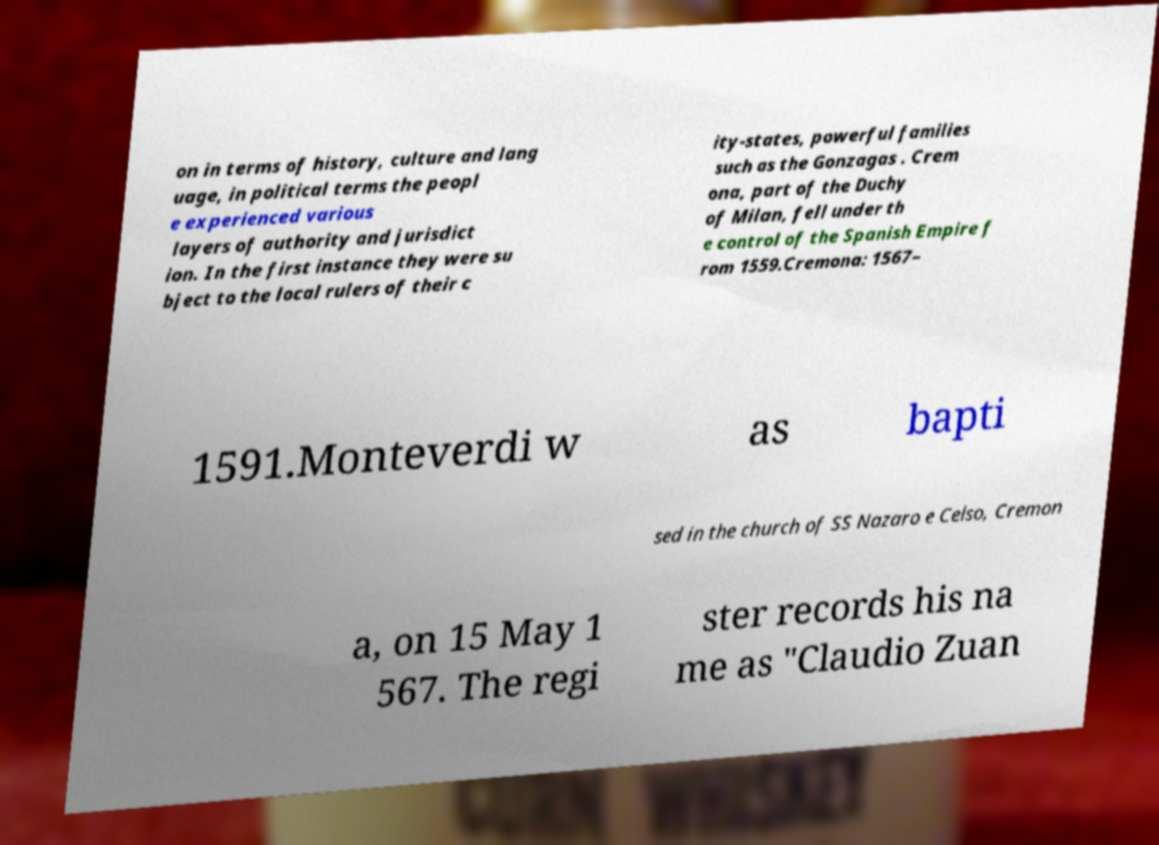Please identify and transcribe the text found in this image. on in terms of history, culture and lang uage, in political terms the peopl e experienced various layers of authority and jurisdict ion. In the first instance they were su bject to the local rulers of their c ity-states, powerful families such as the Gonzagas . Crem ona, part of the Duchy of Milan, fell under th e control of the Spanish Empire f rom 1559.Cremona: 1567– 1591.Monteverdi w as bapti sed in the church of SS Nazaro e Celso, Cremon a, on 15 May 1 567. The regi ster records his na me as "Claudio Zuan 